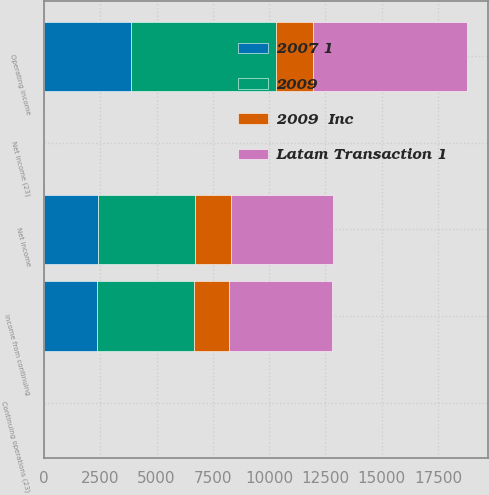Convert chart. <chart><loc_0><loc_0><loc_500><loc_500><stacked_bar_chart><ecel><fcel>Operating income<fcel>Income from continuing<fcel>Net income<fcel>Continuing operations (23)<fcel>Net income (23)<nl><fcel>Latam Transaction 1<fcel>6841<fcel>4551<fcel>4551<fcel>4.11<fcel>4.11<nl><fcel>2009<fcel>6443<fcel>4313<fcel>4313<fcel>3.76<fcel>3.76<nl><fcel>2007 1<fcel>3879<fcel>2335<fcel>2395<fcel>1.93<fcel>1.98<nl><fcel>2009  Inc<fcel>1641<fcel>1579<fcel>1579<fcel>1.3<fcel>1.3<nl></chart> 